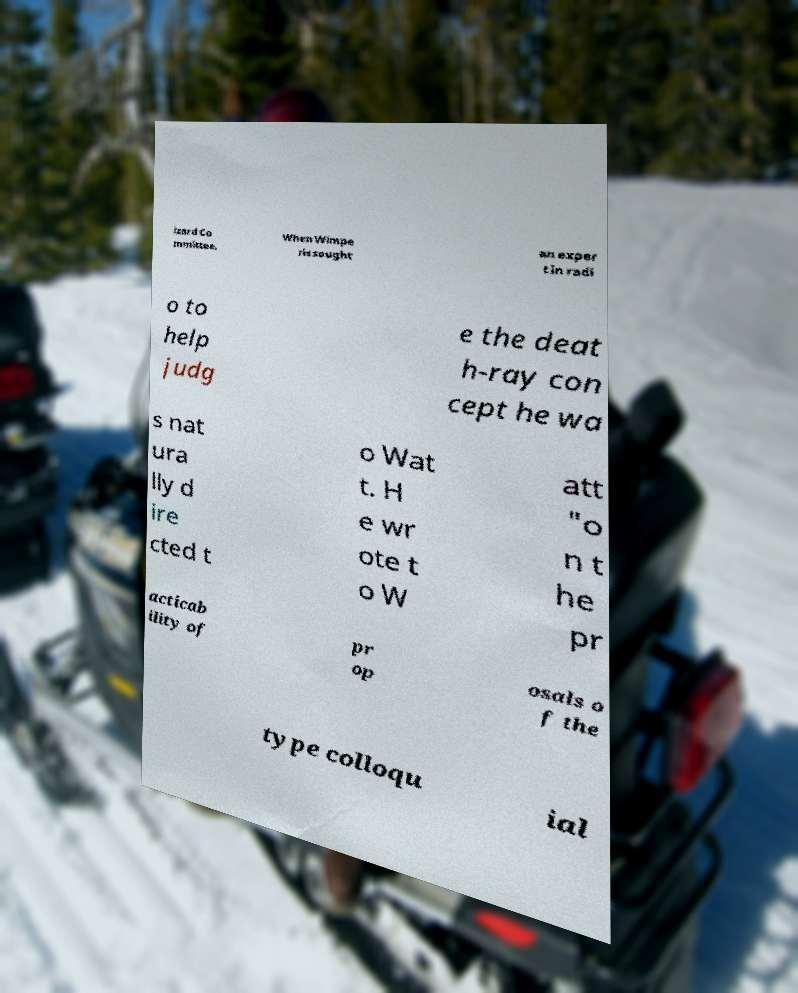Could you assist in decoding the text presented in this image and type it out clearly? izard Co mmittee. When Wimpe ris sought an exper t in radi o to help judg e the deat h-ray con cept he wa s nat ura lly d ire cted t o Wat t. H e wr ote t o W att "o n t he pr acticab ility of pr op osals o f the type colloqu ial 